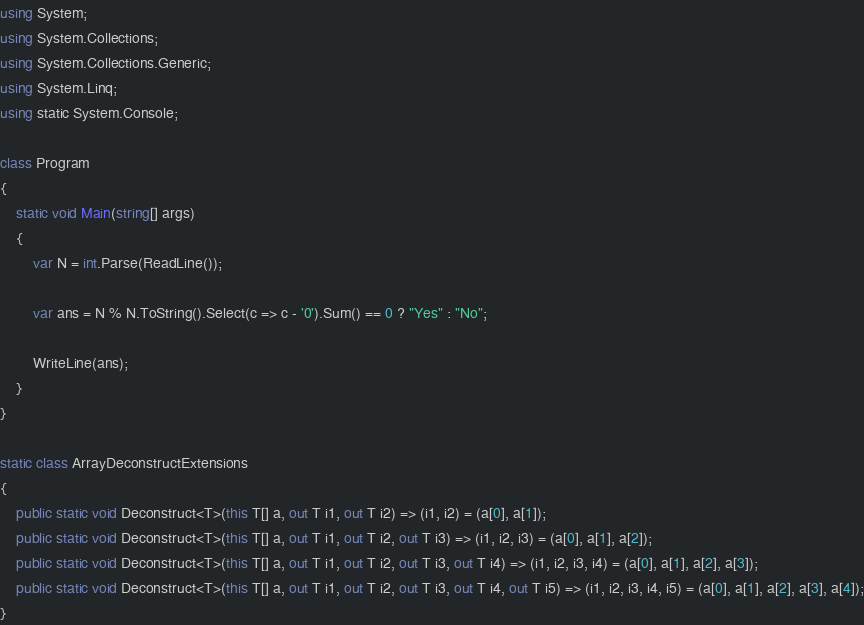<code> <loc_0><loc_0><loc_500><loc_500><_C#_>using System;
using System.Collections;
using System.Collections.Generic;
using System.Linq;
using static System.Console;

class Program
{
    static void Main(string[] args)
    {
        var N = int.Parse(ReadLine());

        var ans = N % N.ToString().Select(c => c - '0').Sum() == 0 ? "Yes" : "No";

        WriteLine(ans);
    }
}

static class ArrayDeconstructExtensions
{
    public static void Deconstruct<T>(this T[] a, out T i1, out T i2) => (i1, i2) = (a[0], a[1]);
    public static void Deconstruct<T>(this T[] a, out T i1, out T i2, out T i3) => (i1, i2, i3) = (a[0], a[1], a[2]);
    public static void Deconstruct<T>(this T[] a, out T i1, out T i2, out T i3, out T i4) => (i1, i2, i3, i4) = (a[0], a[1], a[2], a[3]);
    public static void Deconstruct<T>(this T[] a, out T i1, out T i2, out T i3, out T i4, out T i5) => (i1, i2, i3, i4, i5) = (a[0], a[1], a[2], a[3], a[4]);
}
</code> 